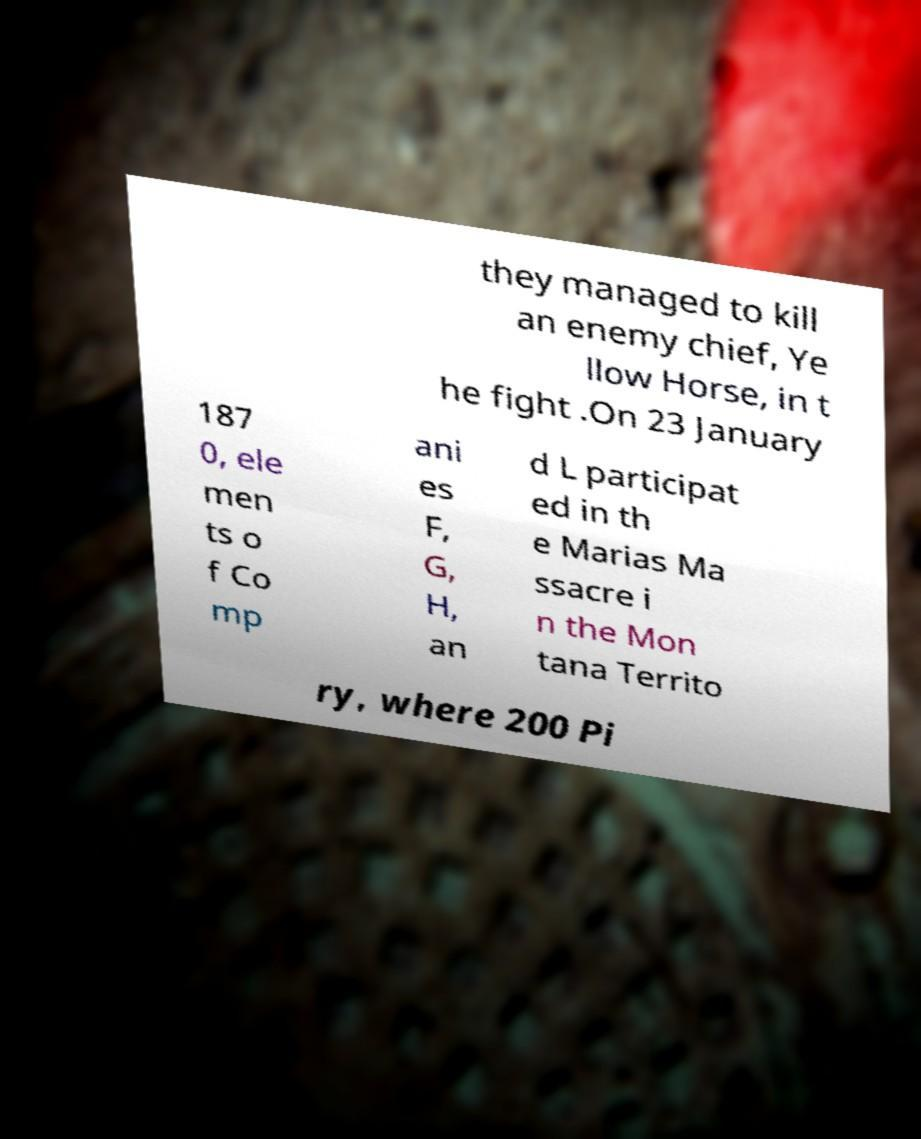For documentation purposes, I need the text within this image transcribed. Could you provide that? they managed to kill an enemy chief, Ye llow Horse, in t he fight .On 23 January 187 0, ele men ts o f Co mp ani es F, G, H, an d L participat ed in th e Marias Ma ssacre i n the Mon tana Territo ry, where 200 Pi 